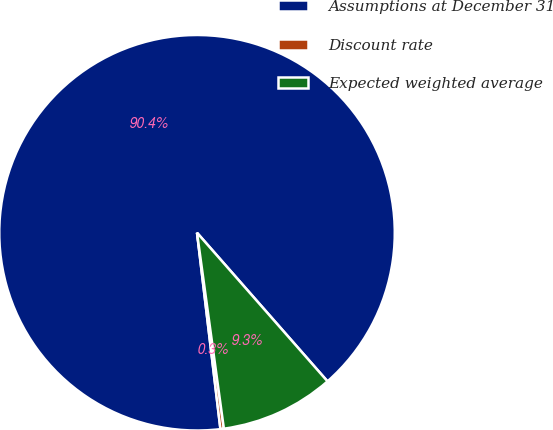Convert chart. <chart><loc_0><loc_0><loc_500><loc_500><pie_chart><fcel>Assumptions at December 31<fcel>Discount rate<fcel>Expected weighted average<nl><fcel>90.42%<fcel>0.28%<fcel>9.3%<nl></chart> 